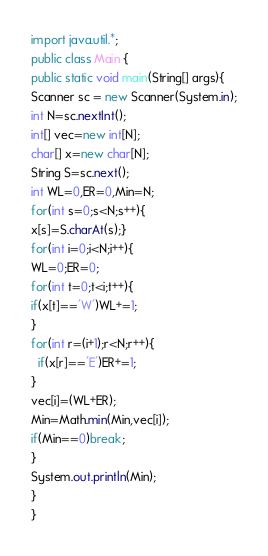Convert code to text. <code><loc_0><loc_0><loc_500><loc_500><_Java_>import java.util.*;
public class Main {
public static void main(String[] args){
Scanner sc = new Scanner(System.in);
int N=sc.nextInt();
int[] vec=new int[N];
char[] x=new char[N];
String S=sc.next();
int WL=0,ER=0,Min=N;
for(int s=0;s<N;s++){
x[s]=S.charAt(s);}
for(int i=0;i<N;i++){
WL=0;ER=0;
for(int t=0;t<i;t++){
if(x[t]=='W')WL+=1;
}
for(int r=(i+1);r<N;r++){
  if(x[r]=='E')ER+=1;
}
vec[i]=(WL+ER);
Min=Math.min(Min,vec[i]);
if(Min==0)break;
}
System.out.println(Min);
}
}
</code> 